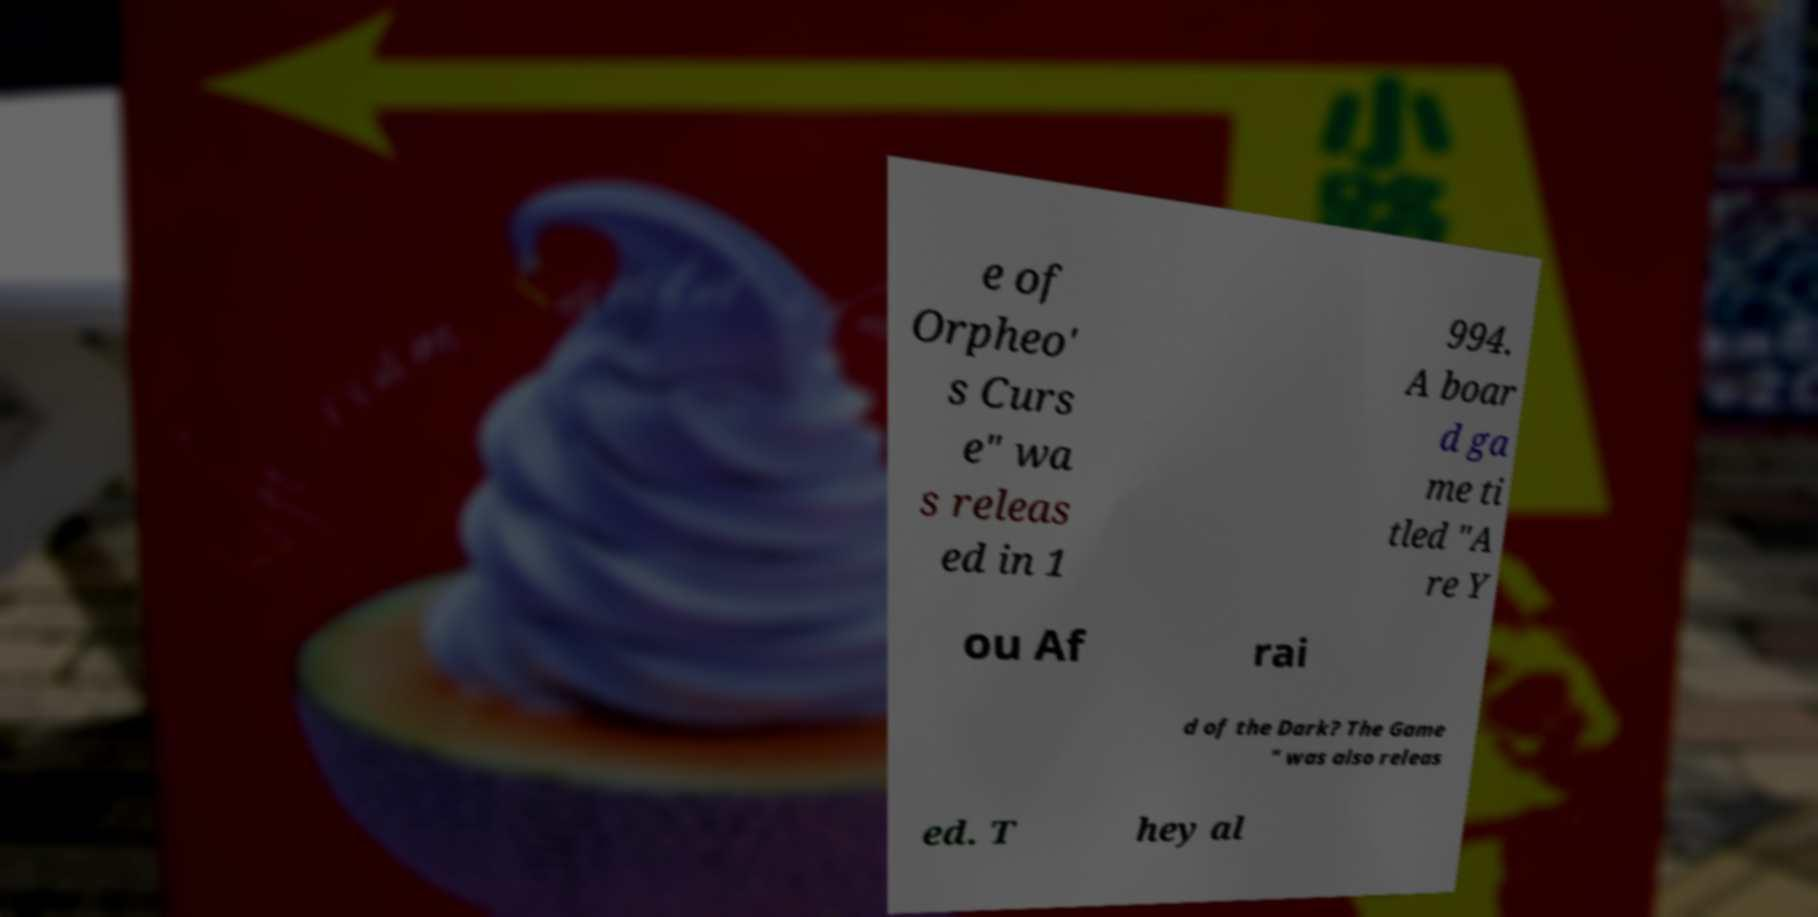I need the written content from this picture converted into text. Can you do that? e of Orpheo' s Curs e" wa s releas ed in 1 994. A boar d ga me ti tled "A re Y ou Af rai d of the Dark? The Game " was also releas ed. T hey al 